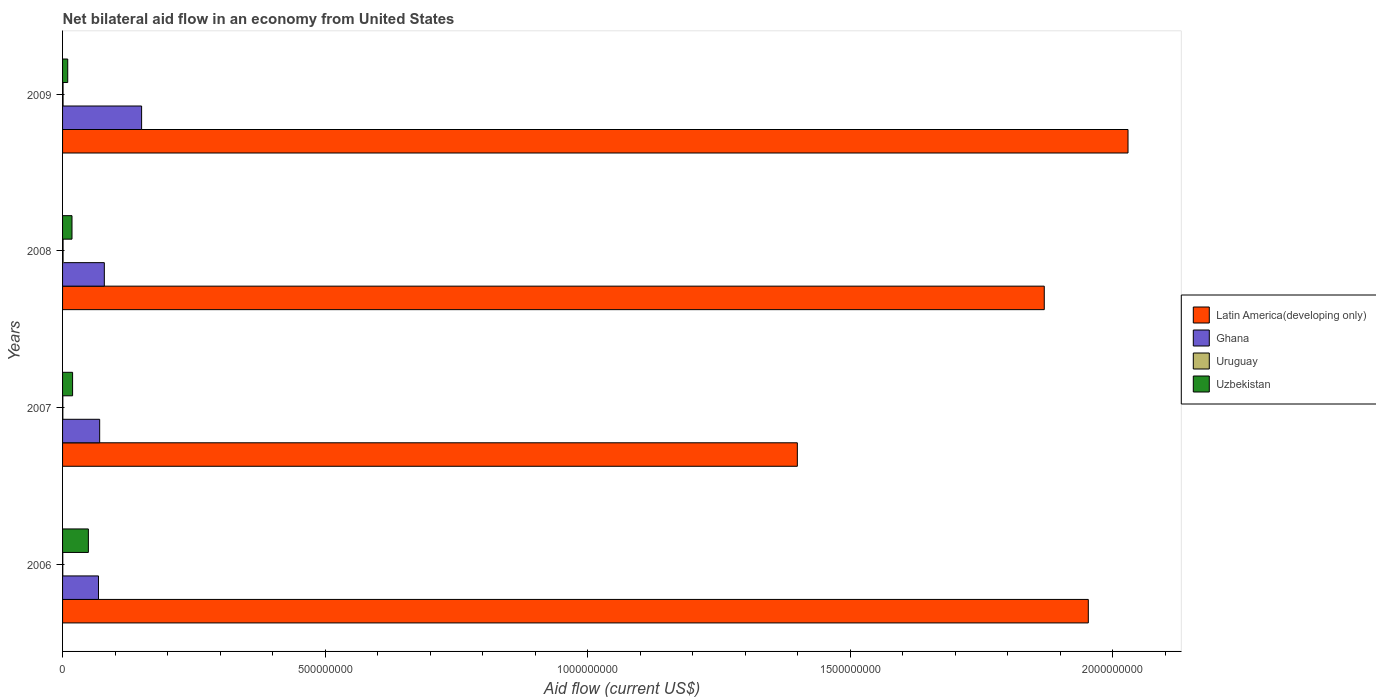How many different coloured bars are there?
Provide a succinct answer. 4. Are the number of bars per tick equal to the number of legend labels?
Your answer should be compact. Yes. Are the number of bars on each tick of the Y-axis equal?
Keep it short and to the point. Yes. How many bars are there on the 4th tick from the top?
Make the answer very short. 4. What is the label of the 3rd group of bars from the top?
Make the answer very short. 2007. What is the net bilateral aid flow in Latin America(developing only) in 2008?
Keep it short and to the point. 1.87e+09. Across all years, what is the maximum net bilateral aid flow in Latin America(developing only)?
Offer a terse response. 2.03e+09. Across all years, what is the minimum net bilateral aid flow in Ghana?
Your answer should be very brief. 6.84e+07. In which year was the net bilateral aid flow in Ghana minimum?
Offer a very short reply. 2006. What is the total net bilateral aid flow in Uruguay in the graph?
Make the answer very short. 2.85e+06. What is the difference between the net bilateral aid flow in Latin America(developing only) in 2006 and that in 2007?
Offer a terse response. 5.54e+08. What is the difference between the net bilateral aid flow in Uruguay in 2006 and the net bilateral aid flow in Latin America(developing only) in 2008?
Keep it short and to the point. -1.87e+09. What is the average net bilateral aid flow in Ghana per year?
Your response must be concise. 9.23e+07. In the year 2009, what is the difference between the net bilateral aid flow in Uzbekistan and net bilateral aid flow in Uruguay?
Provide a succinct answer. 8.89e+06. What is the ratio of the net bilateral aid flow in Ghana in 2006 to that in 2009?
Your response must be concise. 0.45. Is the difference between the net bilateral aid flow in Uzbekistan in 2006 and 2007 greater than the difference between the net bilateral aid flow in Uruguay in 2006 and 2007?
Keep it short and to the point. Yes. What is the difference between the highest and the second highest net bilateral aid flow in Latin America(developing only)?
Your answer should be compact. 7.56e+07. What is the difference between the highest and the lowest net bilateral aid flow in Ghana?
Offer a terse response. 8.21e+07. Is the sum of the net bilateral aid flow in Latin America(developing only) in 2007 and 2009 greater than the maximum net bilateral aid flow in Uzbekistan across all years?
Provide a short and direct response. Yes. Is it the case that in every year, the sum of the net bilateral aid flow in Latin America(developing only) and net bilateral aid flow in Uruguay is greater than the sum of net bilateral aid flow in Uzbekistan and net bilateral aid flow in Ghana?
Give a very brief answer. Yes. What does the 3rd bar from the top in 2009 represents?
Ensure brevity in your answer.  Ghana. What does the 4th bar from the bottom in 2007 represents?
Ensure brevity in your answer.  Uzbekistan. Is it the case that in every year, the sum of the net bilateral aid flow in Ghana and net bilateral aid flow in Latin America(developing only) is greater than the net bilateral aid flow in Uruguay?
Provide a succinct answer. Yes. Are all the bars in the graph horizontal?
Provide a short and direct response. Yes. How many years are there in the graph?
Your answer should be very brief. 4. What is the difference between two consecutive major ticks on the X-axis?
Offer a terse response. 5.00e+08. Are the values on the major ticks of X-axis written in scientific E-notation?
Make the answer very short. No. Does the graph contain grids?
Your response must be concise. No. How are the legend labels stacked?
Keep it short and to the point. Vertical. What is the title of the graph?
Keep it short and to the point. Net bilateral aid flow in an economy from United States. Does "Bulgaria" appear as one of the legend labels in the graph?
Offer a very short reply. No. What is the label or title of the X-axis?
Give a very brief answer. Aid flow (current US$). What is the Aid flow (current US$) of Latin America(developing only) in 2006?
Your answer should be compact. 1.95e+09. What is the Aid flow (current US$) of Ghana in 2006?
Offer a terse response. 6.84e+07. What is the Aid flow (current US$) of Uruguay in 2006?
Make the answer very short. 4.00e+05. What is the Aid flow (current US$) of Uzbekistan in 2006?
Give a very brief answer. 4.92e+07. What is the Aid flow (current US$) in Latin America(developing only) in 2007?
Ensure brevity in your answer.  1.40e+09. What is the Aid flow (current US$) of Ghana in 2007?
Offer a very short reply. 7.07e+07. What is the Aid flow (current US$) of Uruguay in 2007?
Offer a terse response. 5.20e+05. What is the Aid flow (current US$) in Uzbekistan in 2007?
Offer a terse response. 1.91e+07. What is the Aid flow (current US$) of Latin America(developing only) in 2008?
Your answer should be compact. 1.87e+09. What is the Aid flow (current US$) in Ghana in 2008?
Offer a very short reply. 7.95e+07. What is the Aid flow (current US$) in Uruguay in 2008?
Offer a very short reply. 9.70e+05. What is the Aid flow (current US$) in Uzbekistan in 2008?
Your answer should be compact. 1.80e+07. What is the Aid flow (current US$) in Latin America(developing only) in 2009?
Ensure brevity in your answer.  2.03e+09. What is the Aid flow (current US$) of Ghana in 2009?
Offer a terse response. 1.51e+08. What is the Aid flow (current US$) of Uruguay in 2009?
Your response must be concise. 9.60e+05. What is the Aid flow (current US$) of Uzbekistan in 2009?
Your answer should be compact. 9.85e+06. Across all years, what is the maximum Aid flow (current US$) of Latin America(developing only)?
Ensure brevity in your answer.  2.03e+09. Across all years, what is the maximum Aid flow (current US$) of Ghana?
Your answer should be compact. 1.51e+08. Across all years, what is the maximum Aid flow (current US$) in Uruguay?
Your answer should be very brief. 9.70e+05. Across all years, what is the maximum Aid flow (current US$) of Uzbekistan?
Keep it short and to the point. 4.92e+07. Across all years, what is the minimum Aid flow (current US$) of Latin America(developing only)?
Your answer should be compact. 1.40e+09. Across all years, what is the minimum Aid flow (current US$) in Ghana?
Provide a short and direct response. 6.84e+07. Across all years, what is the minimum Aid flow (current US$) in Uzbekistan?
Make the answer very short. 9.85e+06. What is the total Aid flow (current US$) in Latin America(developing only) in the graph?
Your answer should be very brief. 7.25e+09. What is the total Aid flow (current US$) in Ghana in the graph?
Your answer should be compact. 3.69e+08. What is the total Aid flow (current US$) in Uruguay in the graph?
Your response must be concise. 2.85e+06. What is the total Aid flow (current US$) of Uzbekistan in the graph?
Provide a succinct answer. 9.61e+07. What is the difference between the Aid flow (current US$) in Latin America(developing only) in 2006 and that in 2007?
Give a very brief answer. 5.54e+08. What is the difference between the Aid flow (current US$) of Ghana in 2006 and that in 2007?
Ensure brevity in your answer.  -2.24e+06. What is the difference between the Aid flow (current US$) of Uzbekistan in 2006 and that in 2007?
Your answer should be compact. 3.00e+07. What is the difference between the Aid flow (current US$) of Latin America(developing only) in 2006 and that in 2008?
Offer a very short reply. 8.39e+07. What is the difference between the Aid flow (current US$) in Ghana in 2006 and that in 2008?
Your response must be concise. -1.11e+07. What is the difference between the Aid flow (current US$) in Uruguay in 2006 and that in 2008?
Offer a very short reply. -5.70e+05. What is the difference between the Aid flow (current US$) in Uzbekistan in 2006 and that in 2008?
Give a very brief answer. 3.12e+07. What is the difference between the Aid flow (current US$) in Latin America(developing only) in 2006 and that in 2009?
Keep it short and to the point. -7.56e+07. What is the difference between the Aid flow (current US$) of Ghana in 2006 and that in 2009?
Provide a short and direct response. -8.21e+07. What is the difference between the Aid flow (current US$) in Uruguay in 2006 and that in 2009?
Keep it short and to the point. -5.60e+05. What is the difference between the Aid flow (current US$) in Uzbekistan in 2006 and that in 2009?
Your response must be concise. 3.93e+07. What is the difference between the Aid flow (current US$) of Latin America(developing only) in 2007 and that in 2008?
Provide a short and direct response. -4.70e+08. What is the difference between the Aid flow (current US$) of Ghana in 2007 and that in 2008?
Ensure brevity in your answer.  -8.87e+06. What is the difference between the Aid flow (current US$) of Uruguay in 2007 and that in 2008?
Your response must be concise. -4.50e+05. What is the difference between the Aid flow (current US$) in Uzbekistan in 2007 and that in 2008?
Make the answer very short. 1.14e+06. What is the difference between the Aid flow (current US$) in Latin America(developing only) in 2007 and that in 2009?
Provide a short and direct response. -6.30e+08. What is the difference between the Aid flow (current US$) of Ghana in 2007 and that in 2009?
Offer a very short reply. -7.99e+07. What is the difference between the Aid flow (current US$) of Uruguay in 2007 and that in 2009?
Your answer should be compact. -4.40e+05. What is the difference between the Aid flow (current US$) in Uzbekistan in 2007 and that in 2009?
Your answer should be compact. 9.25e+06. What is the difference between the Aid flow (current US$) in Latin America(developing only) in 2008 and that in 2009?
Your answer should be compact. -1.60e+08. What is the difference between the Aid flow (current US$) in Ghana in 2008 and that in 2009?
Ensure brevity in your answer.  -7.10e+07. What is the difference between the Aid flow (current US$) in Uzbekistan in 2008 and that in 2009?
Offer a very short reply. 8.11e+06. What is the difference between the Aid flow (current US$) of Latin America(developing only) in 2006 and the Aid flow (current US$) of Ghana in 2007?
Give a very brief answer. 1.88e+09. What is the difference between the Aid flow (current US$) in Latin America(developing only) in 2006 and the Aid flow (current US$) in Uruguay in 2007?
Keep it short and to the point. 1.95e+09. What is the difference between the Aid flow (current US$) in Latin America(developing only) in 2006 and the Aid flow (current US$) in Uzbekistan in 2007?
Your response must be concise. 1.93e+09. What is the difference between the Aid flow (current US$) in Ghana in 2006 and the Aid flow (current US$) in Uruguay in 2007?
Ensure brevity in your answer.  6.79e+07. What is the difference between the Aid flow (current US$) of Ghana in 2006 and the Aid flow (current US$) of Uzbekistan in 2007?
Your answer should be compact. 4.93e+07. What is the difference between the Aid flow (current US$) of Uruguay in 2006 and the Aid flow (current US$) of Uzbekistan in 2007?
Your answer should be very brief. -1.87e+07. What is the difference between the Aid flow (current US$) in Latin America(developing only) in 2006 and the Aid flow (current US$) in Ghana in 2008?
Keep it short and to the point. 1.87e+09. What is the difference between the Aid flow (current US$) of Latin America(developing only) in 2006 and the Aid flow (current US$) of Uruguay in 2008?
Make the answer very short. 1.95e+09. What is the difference between the Aid flow (current US$) of Latin America(developing only) in 2006 and the Aid flow (current US$) of Uzbekistan in 2008?
Your answer should be very brief. 1.94e+09. What is the difference between the Aid flow (current US$) in Ghana in 2006 and the Aid flow (current US$) in Uruguay in 2008?
Provide a succinct answer. 6.74e+07. What is the difference between the Aid flow (current US$) in Ghana in 2006 and the Aid flow (current US$) in Uzbekistan in 2008?
Ensure brevity in your answer.  5.05e+07. What is the difference between the Aid flow (current US$) in Uruguay in 2006 and the Aid flow (current US$) in Uzbekistan in 2008?
Make the answer very short. -1.76e+07. What is the difference between the Aid flow (current US$) of Latin America(developing only) in 2006 and the Aid flow (current US$) of Ghana in 2009?
Provide a succinct answer. 1.80e+09. What is the difference between the Aid flow (current US$) of Latin America(developing only) in 2006 and the Aid flow (current US$) of Uruguay in 2009?
Your answer should be compact. 1.95e+09. What is the difference between the Aid flow (current US$) of Latin America(developing only) in 2006 and the Aid flow (current US$) of Uzbekistan in 2009?
Offer a very short reply. 1.94e+09. What is the difference between the Aid flow (current US$) in Ghana in 2006 and the Aid flow (current US$) in Uruguay in 2009?
Your answer should be very brief. 6.75e+07. What is the difference between the Aid flow (current US$) in Ghana in 2006 and the Aid flow (current US$) in Uzbekistan in 2009?
Keep it short and to the point. 5.86e+07. What is the difference between the Aid flow (current US$) of Uruguay in 2006 and the Aid flow (current US$) of Uzbekistan in 2009?
Your response must be concise. -9.45e+06. What is the difference between the Aid flow (current US$) in Latin America(developing only) in 2007 and the Aid flow (current US$) in Ghana in 2008?
Ensure brevity in your answer.  1.32e+09. What is the difference between the Aid flow (current US$) in Latin America(developing only) in 2007 and the Aid flow (current US$) in Uruguay in 2008?
Make the answer very short. 1.40e+09. What is the difference between the Aid flow (current US$) in Latin America(developing only) in 2007 and the Aid flow (current US$) in Uzbekistan in 2008?
Ensure brevity in your answer.  1.38e+09. What is the difference between the Aid flow (current US$) of Ghana in 2007 and the Aid flow (current US$) of Uruguay in 2008?
Your answer should be compact. 6.97e+07. What is the difference between the Aid flow (current US$) in Ghana in 2007 and the Aid flow (current US$) in Uzbekistan in 2008?
Give a very brief answer. 5.27e+07. What is the difference between the Aid flow (current US$) in Uruguay in 2007 and the Aid flow (current US$) in Uzbekistan in 2008?
Your response must be concise. -1.74e+07. What is the difference between the Aid flow (current US$) in Latin America(developing only) in 2007 and the Aid flow (current US$) in Ghana in 2009?
Give a very brief answer. 1.25e+09. What is the difference between the Aid flow (current US$) of Latin America(developing only) in 2007 and the Aid flow (current US$) of Uruguay in 2009?
Provide a short and direct response. 1.40e+09. What is the difference between the Aid flow (current US$) of Latin America(developing only) in 2007 and the Aid flow (current US$) of Uzbekistan in 2009?
Your answer should be compact. 1.39e+09. What is the difference between the Aid flow (current US$) in Ghana in 2007 and the Aid flow (current US$) in Uruguay in 2009?
Provide a succinct answer. 6.97e+07. What is the difference between the Aid flow (current US$) in Ghana in 2007 and the Aid flow (current US$) in Uzbekistan in 2009?
Give a very brief answer. 6.08e+07. What is the difference between the Aid flow (current US$) in Uruguay in 2007 and the Aid flow (current US$) in Uzbekistan in 2009?
Your answer should be compact. -9.33e+06. What is the difference between the Aid flow (current US$) of Latin America(developing only) in 2008 and the Aid flow (current US$) of Ghana in 2009?
Ensure brevity in your answer.  1.72e+09. What is the difference between the Aid flow (current US$) of Latin America(developing only) in 2008 and the Aid flow (current US$) of Uruguay in 2009?
Provide a succinct answer. 1.87e+09. What is the difference between the Aid flow (current US$) of Latin America(developing only) in 2008 and the Aid flow (current US$) of Uzbekistan in 2009?
Offer a terse response. 1.86e+09. What is the difference between the Aid flow (current US$) in Ghana in 2008 and the Aid flow (current US$) in Uruguay in 2009?
Offer a very short reply. 7.86e+07. What is the difference between the Aid flow (current US$) of Ghana in 2008 and the Aid flow (current US$) of Uzbekistan in 2009?
Provide a succinct answer. 6.97e+07. What is the difference between the Aid flow (current US$) in Uruguay in 2008 and the Aid flow (current US$) in Uzbekistan in 2009?
Give a very brief answer. -8.88e+06. What is the average Aid flow (current US$) of Latin America(developing only) per year?
Ensure brevity in your answer.  1.81e+09. What is the average Aid flow (current US$) of Ghana per year?
Your answer should be very brief. 9.23e+07. What is the average Aid flow (current US$) in Uruguay per year?
Keep it short and to the point. 7.12e+05. What is the average Aid flow (current US$) of Uzbekistan per year?
Your answer should be very brief. 2.40e+07. In the year 2006, what is the difference between the Aid flow (current US$) of Latin America(developing only) and Aid flow (current US$) of Ghana?
Keep it short and to the point. 1.89e+09. In the year 2006, what is the difference between the Aid flow (current US$) of Latin America(developing only) and Aid flow (current US$) of Uruguay?
Ensure brevity in your answer.  1.95e+09. In the year 2006, what is the difference between the Aid flow (current US$) of Latin America(developing only) and Aid flow (current US$) of Uzbekistan?
Give a very brief answer. 1.90e+09. In the year 2006, what is the difference between the Aid flow (current US$) in Ghana and Aid flow (current US$) in Uruguay?
Ensure brevity in your answer.  6.80e+07. In the year 2006, what is the difference between the Aid flow (current US$) in Ghana and Aid flow (current US$) in Uzbekistan?
Your answer should be very brief. 1.93e+07. In the year 2006, what is the difference between the Aid flow (current US$) of Uruguay and Aid flow (current US$) of Uzbekistan?
Make the answer very short. -4.88e+07. In the year 2007, what is the difference between the Aid flow (current US$) in Latin America(developing only) and Aid flow (current US$) in Ghana?
Offer a very short reply. 1.33e+09. In the year 2007, what is the difference between the Aid flow (current US$) in Latin America(developing only) and Aid flow (current US$) in Uruguay?
Keep it short and to the point. 1.40e+09. In the year 2007, what is the difference between the Aid flow (current US$) in Latin America(developing only) and Aid flow (current US$) in Uzbekistan?
Ensure brevity in your answer.  1.38e+09. In the year 2007, what is the difference between the Aid flow (current US$) of Ghana and Aid flow (current US$) of Uruguay?
Make the answer very short. 7.01e+07. In the year 2007, what is the difference between the Aid flow (current US$) in Ghana and Aid flow (current US$) in Uzbekistan?
Offer a very short reply. 5.16e+07. In the year 2007, what is the difference between the Aid flow (current US$) in Uruguay and Aid flow (current US$) in Uzbekistan?
Make the answer very short. -1.86e+07. In the year 2008, what is the difference between the Aid flow (current US$) in Latin America(developing only) and Aid flow (current US$) in Ghana?
Offer a very short reply. 1.79e+09. In the year 2008, what is the difference between the Aid flow (current US$) of Latin America(developing only) and Aid flow (current US$) of Uruguay?
Provide a succinct answer. 1.87e+09. In the year 2008, what is the difference between the Aid flow (current US$) in Latin America(developing only) and Aid flow (current US$) in Uzbekistan?
Your answer should be compact. 1.85e+09. In the year 2008, what is the difference between the Aid flow (current US$) in Ghana and Aid flow (current US$) in Uruguay?
Your answer should be very brief. 7.86e+07. In the year 2008, what is the difference between the Aid flow (current US$) in Ghana and Aid flow (current US$) in Uzbekistan?
Make the answer very short. 6.16e+07. In the year 2008, what is the difference between the Aid flow (current US$) in Uruguay and Aid flow (current US$) in Uzbekistan?
Offer a very short reply. -1.70e+07. In the year 2009, what is the difference between the Aid flow (current US$) in Latin America(developing only) and Aid flow (current US$) in Ghana?
Make the answer very short. 1.88e+09. In the year 2009, what is the difference between the Aid flow (current US$) in Latin America(developing only) and Aid flow (current US$) in Uruguay?
Make the answer very short. 2.03e+09. In the year 2009, what is the difference between the Aid flow (current US$) in Latin America(developing only) and Aid flow (current US$) in Uzbekistan?
Give a very brief answer. 2.02e+09. In the year 2009, what is the difference between the Aid flow (current US$) of Ghana and Aid flow (current US$) of Uruguay?
Your answer should be compact. 1.50e+08. In the year 2009, what is the difference between the Aid flow (current US$) in Ghana and Aid flow (current US$) in Uzbekistan?
Your answer should be very brief. 1.41e+08. In the year 2009, what is the difference between the Aid flow (current US$) of Uruguay and Aid flow (current US$) of Uzbekistan?
Offer a terse response. -8.89e+06. What is the ratio of the Aid flow (current US$) in Latin America(developing only) in 2006 to that in 2007?
Provide a short and direct response. 1.4. What is the ratio of the Aid flow (current US$) of Ghana in 2006 to that in 2007?
Make the answer very short. 0.97. What is the ratio of the Aid flow (current US$) of Uruguay in 2006 to that in 2007?
Keep it short and to the point. 0.77. What is the ratio of the Aid flow (current US$) of Uzbekistan in 2006 to that in 2007?
Your answer should be very brief. 2.57. What is the ratio of the Aid flow (current US$) of Latin America(developing only) in 2006 to that in 2008?
Give a very brief answer. 1.04. What is the ratio of the Aid flow (current US$) in Ghana in 2006 to that in 2008?
Offer a terse response. 0.86. What is the ratio of the Aid flow (current US$) of Uruguay in 2006 to that in 2008?
Offer a very short reply. 0.41. What is the ratio of the Aid flow (current US$) of Uzbekistan in 2006 to that in 2008?
Your response must be concise. 2.74. What is the ratio of the Aid flow (current US$) of Latin America(developing only) in 2006 to that in 2009?
Your response must be concise. 0.96. What is the ratio of the Aid flow (current US$) of Ghana in 2006 to that in 2009?
Make the answer very short. 0.45. What is the ratio of the Aid flow (current US$) of Uruguay in 2006 to that in 2009?
Your answer should be very brief. 0.42. What is the ratio of the Aid flow (current US$) in Uzbekistan in 2006 to that in 2009?
Make the answer very short. 4.99. What is the ratio of the Aid flow (current US$) of Latin America(developing only) in 2007 to that in 2008?
Offer a very short reply. 0.75. What is the ratio of the Aid flow (current US$) of Ghana in 2007 to that in 2008?
Your answer should be very brief. 0.89. What is the ratio of the Aid flow (current US$) in Uruguay in 2007 to that in 2008?
Offer a very short reply. 0.54. What is the ratio of the Aid flow (current US$) in Uzbekistan in 2007 to that in 2008?
Provide a succinct answer. 1.06. What is the ratio of the Aid flow (current US$) of Latin America(developing only) in 2007 to that in 2009?
Your response must be concise. 0.69. What is the ratio of the Aid flow (current US$) of Ghana in 2007 to that in 2009?
Make the answer very short. 0.47. What is the ratio of the Aid flow (current US$) of Uruguay in 2007 to that in 2009?
Your response must be concise. 0.54. What is the ratio of the Aid flow (current US$) in Uzbekistan in 2007 to that in 2009?
Offer a very short reply. 1.94. What is the ratio of the Aid flow (current US$) in Latin America(developing only) in 2008 to that in 2009?
Offer a terse response. 0.92. What is the ratio of the Aid flow (current US$) of Ghana in 2008 to that in 2009?
Your answer should be compact. 0.53. What is the ratio of the Aid flow (current US$) in Uruguay in 2008 to that in 2009?
Make the answer very short. 1.01. What is the ratio of the Aid flow (current US$) of Uzbekistan in 2008 to that in 2009?
Your answer should be compact. 1.82. What is the difference between the highest and the second highest Aid flow (current US$) of Latin America(developing only)?
Make the answer very short. 7.56e+07. What is the difference between the highest and the second highest Aid flow (current US$) of Ghana?
Provide a short and direct response. 7.10e+07. What is the difference between the highest and the second highest Aid flow (current US$) of Uzbekistan?
Provide a short and direct response. 3.00e+07. What is the difference between the highest and the lowest Aid flow (current US$) of Latin America(developing only)?
Provide a short and direct response. 6.30e+08. What is the difference between the highest and the lowest Aid flow (current US$) in Ghana?
Your answer should be compact. 8.21e+07. What is the difference between the highest and the lowest Aid flow (current US$) of Uruguay?
Your answer should be compact. 5.70e+05. What is the difference between the highest and the lowest Aid flow (current US$) in Uzbekistan?
Offer a very short reply. 3.93e+07. 